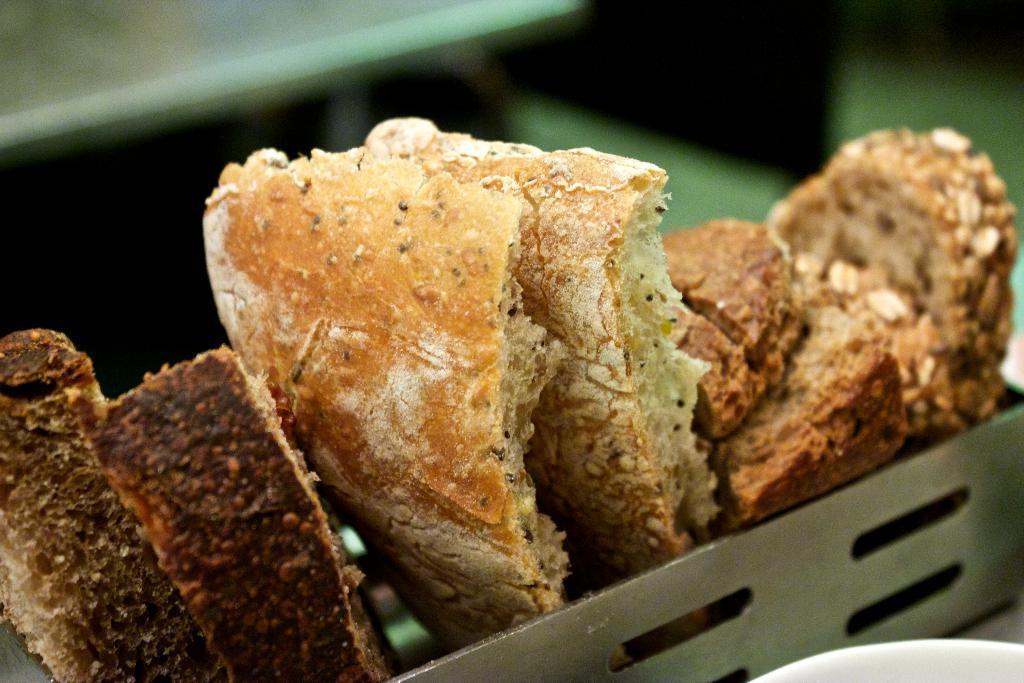Please provide a concise description of this image. In the picture we can see some eatable item placed in the small steel box and behind it, we can see a table which is not clearly visible. 